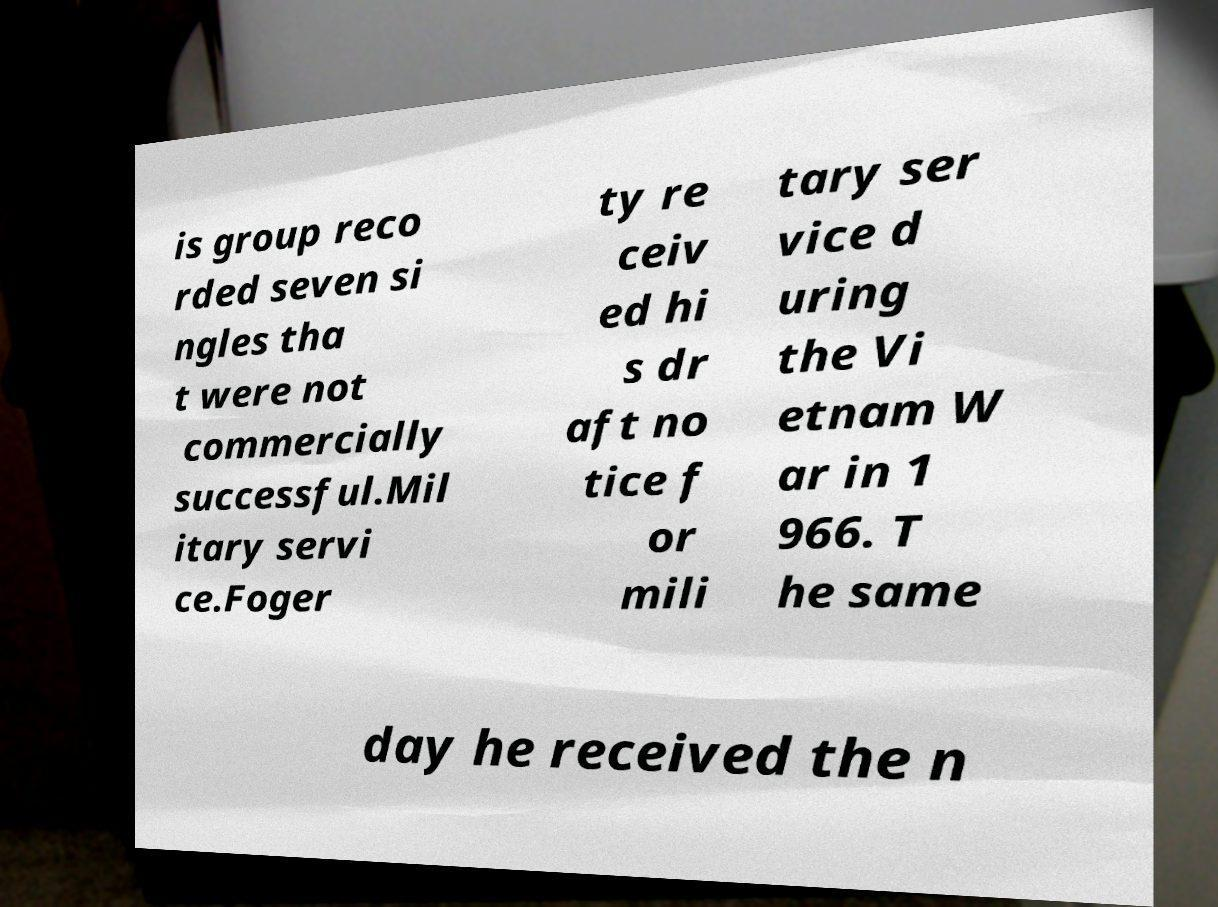Please identify and transcribe the text found in this image. is group reco rded seven si ngles tha t were not commercially successful.Mil itary servi ce.Foger ty re ceiv ed hi s dr aft no tice f or mili tary ser vice d uring the Vi etnam W ar in 1 966. T he same day he received the n 